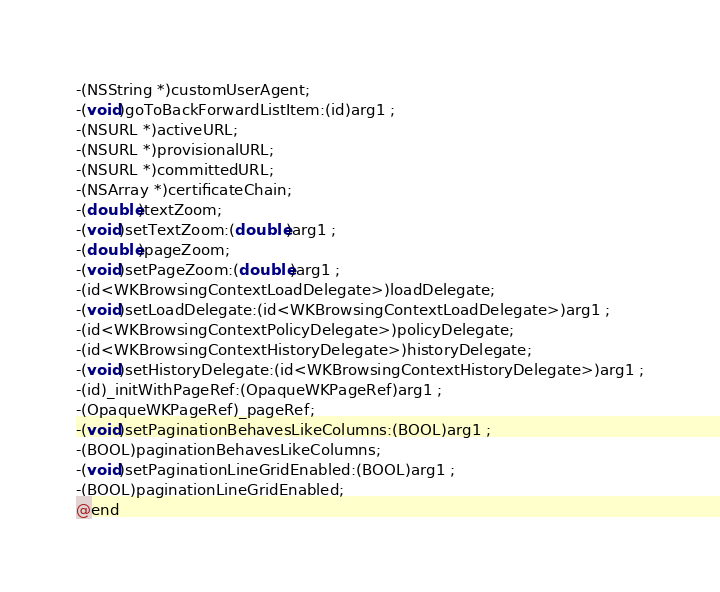Convert code to text. <code><loc_0><loc_0><loc_500><loc_500><_C_>-(NSString *)customUserAgent;
-(void)goToBackForwardListItem:(id)arg1 ;
-(NSURL *)activeURL;
-(NSURL *)provisionalURL;
-(NSURL *)committedURL;
-(NSArray *)certificateChain;
-(double)textZoom;
-(void)setTextZoom:(double)arg1 ;
-(double)pageZoom;
-(void)setPageZoom:(double)arg1 ;
-(id<WKBrowsingContextLoadDelegate>)loadDelegate;
-(void)setLoadDelegate:(id<WKBrowsingContextLoadDelegate>)arg1 ;
-(id<WKBrowsingContextPolicyDelegate>)policyDelegate;
-(id<WKBrowsingContextHistoryDelegate>)historyDelegate;
-(void)setHistoryDelegate:(id<WKBrowsingContextHistoryDelegate>)arg1 ;
-(id)_initWithPageRef:(OpaqueWKPageRef)arg1 ;
-(OpaqueWKPageRef)_pageRef;
-(void)setPaginationBehavesLikeColumns:(BOOL)arg1 ;
-(BOOL)paginationBehavesLikeColumns;
-(void)setPaginationLineGridEnabled:(BOOL)arg1 ;
-(BOOL)paginationLineGridEnabled;
@end

</code> 